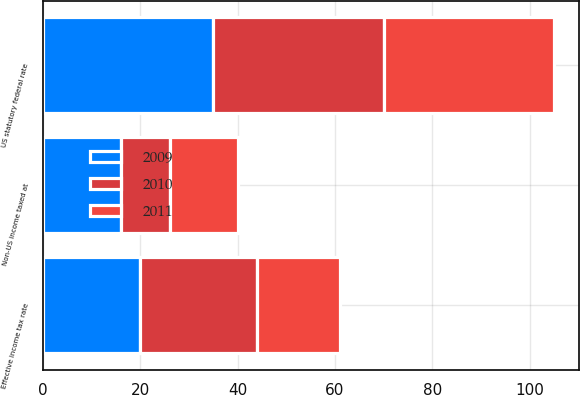Convert chart to OTSL. <chart><loc_0><loc_0><loc_500><loc_500><stacked_bar_chart><ecel><fcel>US statutory federal rate<fcel>Non-US income taxed at<fcel>Effective income tax rate<nl><fcel>2010<fcel>35<fcel>10<fcel>24<nl><fcel>2011<fcel>35<fcel>14<fcel>17<nl><fcel>2009<fcel>35<fcel>16<fcel>20<nl></chart> 